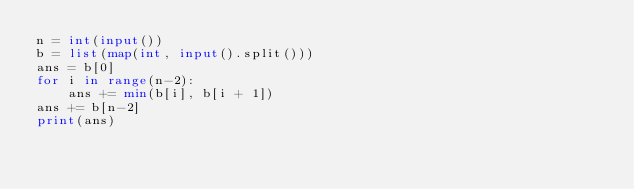<code> <loc_0><loc_0><loc_500><loc_500><_Python_>n = int(input())
b = list(map(int, input().split()))
ans = b[0]
for i in range(n-2):
    ans += min(b[i], b[i + 1])
ans += b[n-2]
print(ans)
</code> 